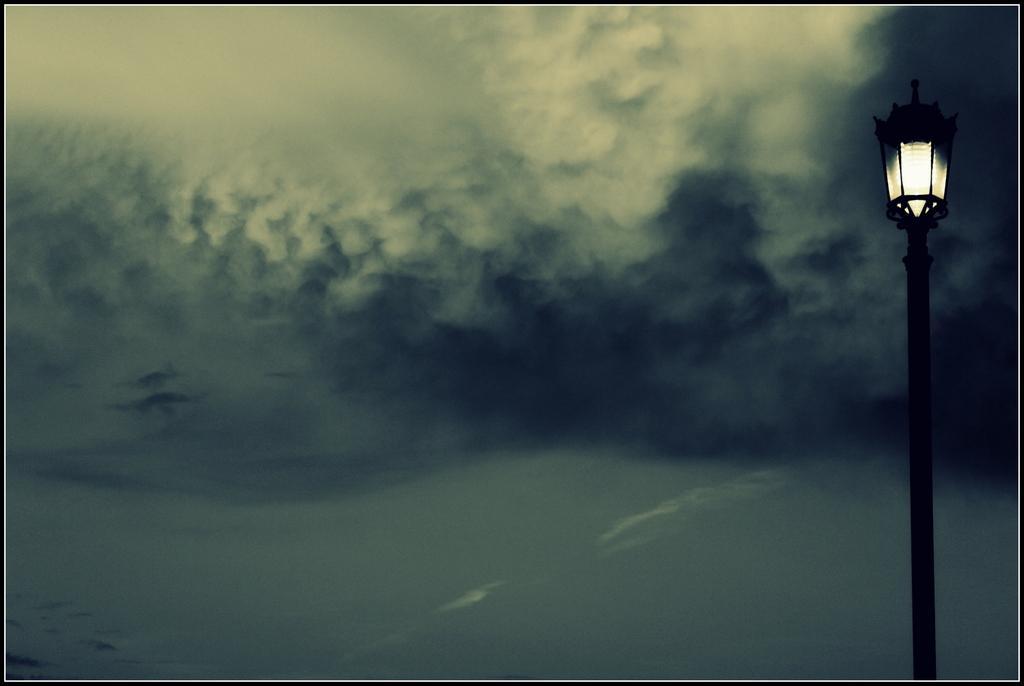In one or two sentences, can you explain what this image depicts? In this image I can see the light pole. In the background I can see the clouds and the sky. 